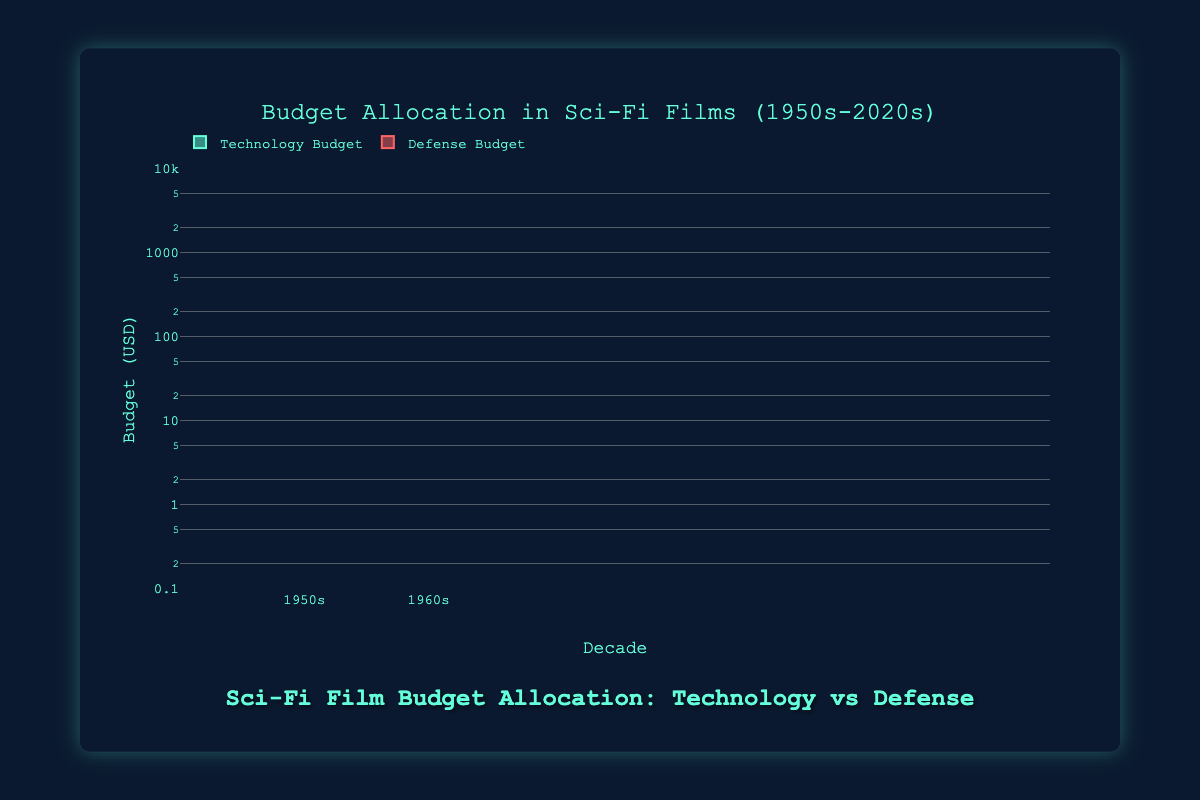What's the title of the figure? The title is typically located at the top of the figure in a larger and bold font. In this case, the title text is "Budget Allocation in Sci-Fi Films (1950s-2020s)."
Answer: Budget Allocation in Sci-Fi Films (1950s-2020s) What are the two categories shown in the box plot? By examining the legend or the different colored box plots, we can identify the categories. The labels show "Technology Budget" and "Defense Budget."
Answer: Technology Budget, Defense Budget In which decade does the Technology Budget seem to have the highest upper whisker in the box plot? By identifying the uppermost point of the Technology Budget box plots across different decades, the 2020s decade has the highest upper whisker (reaching up to the upper budget values).
Answer: 2020s Which decade displays the highest median Technology Budget? The median is typically represented by a line inside each box. By examining each decade, it is clear that the 2020s have the highest median Technology Budget.
Answer: 2020s How does the median Defense Budget in the 1990s compare to that in the 2000s? To compare, check the median lines in both decades. The 1990s median Defense Budget is lower than that of the 2000s.
Answer: Lower in the 1990s In which decade is there the largest spread (interquartile range) in the Defense Budget? The spread or interquartile range (IQR) can be observed by the height of the box. The 1990s Defense Budget box has the largest spread.
Answer: 1990s How do the budgets of Defense and Technology compare in the 1970s? Both box plots' positions show that the median Defense Budget is greater than the median Technology Budget in the 1970s.
Answer: Defense > Technology Is there a trend in the median Technology Budget from the 1950s to the 2020s? By analyzing the position of the median lines over decades, the median Technology Budget shows an overall increasing trend.
Answer: Increasing trend What is the range of the Technology Budget in the 1960s? By looking at the lowest and highest points (whiskers) of the Technology Budget in the 1960s, the range is from 3,000,000 to 6,000,000 USD.
Answer: 3,000,000 to 6,000,000 USD 